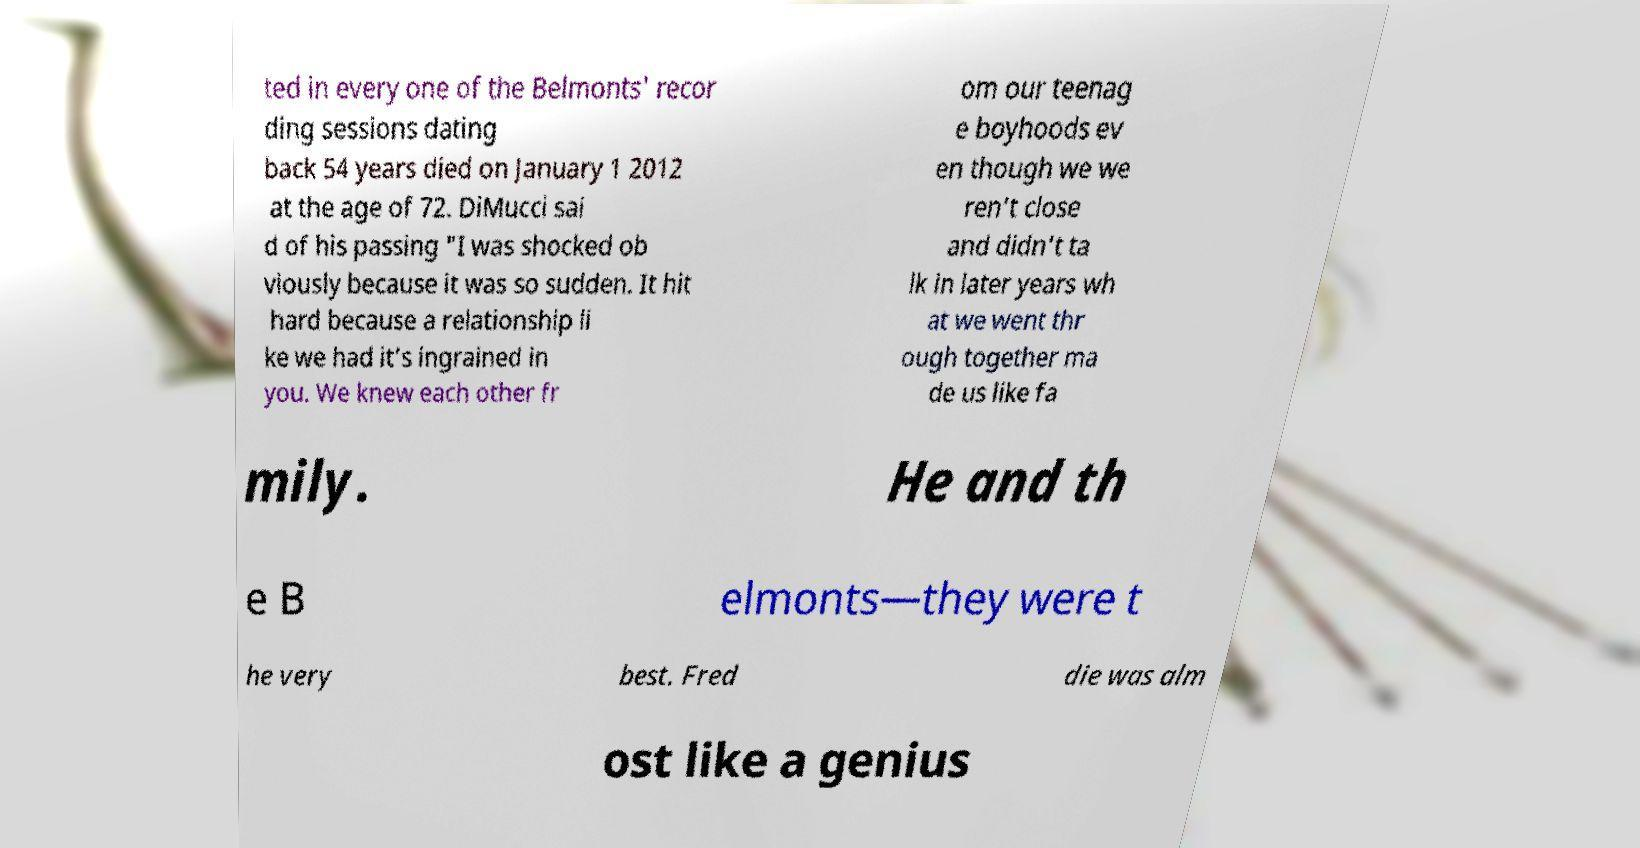There's text embedded in this image that I need extracted. Can you transcribe it verbatim? ted in every one of the Belmonts' recor ding sessions dating back 54 years died on January 1 2012 at the age of 72. DiMucci sai d of his passing "I was shocked ob viously because it was so sudden. It hit hard because a relationship li ke we had it’s ingrained in you. We knew each other fr om our teenag e boyhoods ev en though we we ren’t close and didn’t ta lk in later years wh at we went thr ough together ma de us like fa mily. He and th e B elmonts—they were t he very best. Fred die was alm ost like a genius 